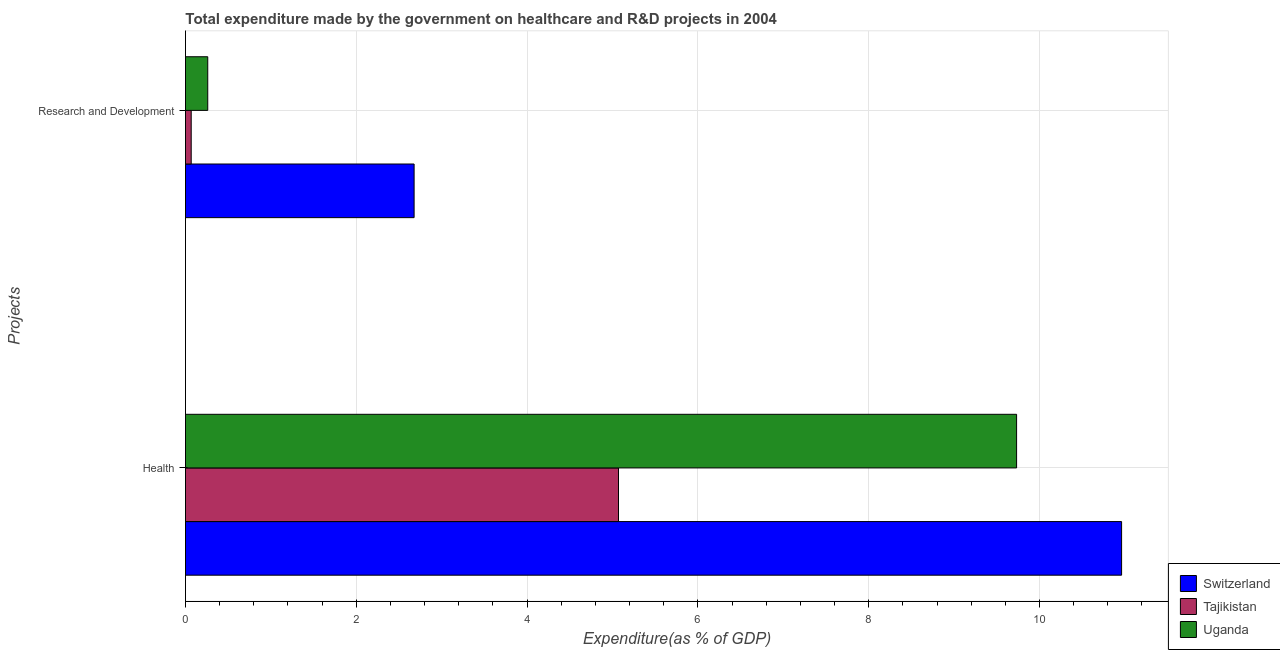How many different coloured bars are there?
Give a very brief answer. 3. Are the number of bars per tick equal to the number of legend labels?
Provide a short and direct response. Yes. How many bars are there on the 2nd tick from the top?
Offer a very short reply. 3. How many bars are there on the 1st tick from the bottom?
Your answer should be compact. 3. What is the label of the 1st group of bars from the top?
Your response must be concise. Research and Development. What is the expenditure in healthcare in Switzerland?
Offer a very short reply. 10.96. Across all countries, what is the maximum expenditure in healthcare?
Offer a terse response. 10.96. Across all countries, what is the minimum expenditure in r&d?
Your answer should be very brief. 0.07. In which country was the expenditure in healthcare maximum?
Your response must be concise. Switzerland. In which country was the expenditure in healthcare minimum?
Provide a short and direct response. Tajikistan. What is the total expenditure in healthcare in the graph?
Offer a very short reply. 25.76. What is the difference between the expenditure in healthcare in Switzerland and that in Tajikistan?
Provide a succinct answer. 5.89. What is the difference between the expenditure in healthcare in Switzerland and the expenditure in r&d in Tajikistan?
Make the answer very short. 10.89. What is the average expenditure in r&d per country?
Your response must be concise. 1. What is the difference between the expenditure in healthcare and expenditure in r&d in Switzerland?
Ensure brevity in your answer.  8.28. In how many countries, is the expenditure in r&d greater than 8 %?
Offer a terse response. 0. What is the ratio of the expenditure in r&d in Uganda to that in Switzerland?
Provide a short and direct response. 0.1. Is the expenditure in r&d in Tajikistan less than that in Switzerland?
Provide a succinct answer. Yes. In how many countries, is the expenditure in r&d greater than the average expenditure in r&d taken over all countries?
Make the answer very short. 1. What does the 2nd bar from the top in Health represents?
Provide a succinct answer. Tajikistan. What does the 1st bar from the bottom in Research and Development represents?
Make the answer very short. Switzerland. How many bars are there?
Your response must be concise. 6. What is the difference between two consecutive major ticks on the X-axis?
Offer a very short reply. 2. Does the graph contain grids?
Keep it short and to the point. Yes. Where does the legend appear in the graph?
Provide a short and direct response. Bottom right. How many legend labels are there?
Your response must be concise. 3. What is the title of the graph?
Keep it short and to the point. Total expenditure made by the government on healthcare and R&D projects in 2004. Does "Low & middle income" appear as one of the legend labels in the graph?
Provide a succinct answer. No. What is the label or title of the X-axis?
Ensure brevity in your answer.  Expenditure(as % of GDP). What is the label or title of the Y-axis?
Give a very brief answer. Projects. What is the Expenditure(as % of GDP) in Switzerland in Health?
Your response must be concise. 10.96. What is the Expenditure(as % of GDP) of Tajikistan in Health?
Your response must be concise. 5.07. What is the Expenditure(as % of GDP) in Uganda in Health?
Provide a short and direct response. 9.73. What is the Expenditure(as % of GDP) in Switzerland in Research and Development?
Provide a succinct answer. 2.68. What is the Expenditure(as % of GDP) in Tajikistan in Research and Development?
Your response must be concise. 0.07. What is the Expenditure(as % of GDP) in Uganda in Research and Development?
Offer a terse response. 0.26. Across all Projects, what is the maximum Expenditure(as % of GDP) of Switzerland?
Your answer should be very brief. 10.96. Across all Projects, what is the maximum Expenditure(as % of GDP) of Tajikistan?
Offer a very short reply. 5.07. Across all Projects, what is the maximum Expenditure(as % of GDP) of Uganda?
Ensure brevity in your answer.  9.73. Across all Projects, what is the minimum Expenditure(as % of GDP) of Switzerland?
Offer a terse response. 2.68. Across all Projects, what is the minimum Expenditure(as % of GDP) in Tajikistan?
Offer a terse response. 0.07. Across all Projects, what is the minimum Expenditure(as % of GDP) of Uganda?
Make the answer very short. 0.26. What is the total Expenditure(as % of GDP) in Switzerland in the graph?
Keep it short and to the point. 13.64. What is the total Expenditure(as % of GDP) in Tajikistan in the graph?
Provide a succinct answer. 5.14. What is the total Expenditure(as % of GDP) in Uganda in the graph?
Make the answer very short. 9.99. What is the difference between the Expenditure(as % of GDP) in Switzerland in Health and that in Research and Development?
Your answer should be very brief. 8.28. What is the difference between the Expenditure(as % of GDP) of Tajikistan in Health and that in Research and Development?
Your response must be concise. 5. What is the difference between the Expenditure(as % of GDP) of Uganda in Health and that in Research and Development?
Your answer should be compact. 9.47. What is the difference between the Expenditure(as % of GDP) in Switzerland in Health and the Expenditure(as % of GDP) in Tajikistan in Research and Development?
Keep it short and to the point. 10.89. What is the difference between the Expenditure(as % of GDP) of Switzerland in Health and the Expenditure(as % of GDP) of Uganda in Research and Development?
Provide a succinct answer. 10.7. What is the difference between the Expenditure(as % of GDP) of Tajikistan in Health and the Expenditure(as % of GDP) of Uganda in Research and Development?
Give a very brief answer. 4.81. What is the average Expenditure(as % of GDP) in Switzerland per Projects?
Provide a short and direct response. 6.82. What is the average Expenditure(as % of GDP) in Tajikistan per Projects?
Make the answer very short. 2.57. What is the average Expenditure(as % of GDP) in Uganda per Projects?
Provide a succinct answer. 5. What is the difference between the Expenditure(as % of GDP) of Switzerland and Expenditure(as % of GDP) of Tajikistan in Health?
Your answer should be compact. 5.89. What is the difference between the Expenditure(as % of GDP) in Switzerland and Expenditure(as % of GDP) in Uganda in Health?
Offer a terse response. 1.23. What is the difference between the Expenditure(as % of GDP) in Tajikistan and Expenditure(as % of GDP) in Uganda in Health?
Your response must be concise. -4.66. What is the difference between the Expenditure(as % of GDP) of Switzerland and Expenditure(as % of GDP) of Tajikistan in Research and Development?
Provide a short and direct response. 2.61. What is the difference between the Expenditure(as % of GDP) of Switzerland and Expenditure(as % of GDP) of Uganda in Research and Development?
Keep it short and to the point. 2.42. What is the difference between the Expenditure(as % of GDP) in Tajikistan and Expenditure(as % of GDP) in Uganda in Research and Development?
Offer a very short reply. -0.19. What is the ratio of the Expenditure(as % of GDP) in Switzerland in Health to that in Research and Development?
Provide a short and direct response. 4.09. What is the ratio of the Expenditure(as % of GDP) of Tajikistan in Health to that in Research and Development?
Give a very brief answer. 75.71. What is the ratio of the Expenditure(as % of GDP) in Uganda in Health to that in Research and Development?
Provide a short and direct response. 37.35. What is the difference between the highest and the second highest Expenditure(as % of GDP) in Switzerland?
Provide a short and direct response. 8.28. What is the difference between the highest and the second highest Expenditure(as % of GDP) in Tajikistan?
Keep it short and to the point. 5. What is the difference between the highest and the second highest Expenditure(as % of GDP) of Uganda?
Provide a short and direct response. 9.47. What is the difference between the highest and the lowest Expenditure(as % of GDP) in Switzerland?
Provide a succinct answer. 8.28. What is the difference between the highest and the lowest Expenditure(as % of GDP) in Tajikistan?
Offer a terse response. 5. What is the difference between the highest and the lowest Expenditure(as % of GDP) in Uganda?
Provide a succinct answer. 9.47. 